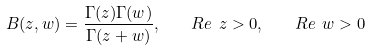<formula> <loc_0><loc_0><loc_500><loc_500>B ( z , w ) = \frac { \Gamma ( z ) \Gamma ( w ) } { \Gamma ( z + w ) } , \quad R e \ { z } > 0 , \quad R e \ { w } > 0</formula> 